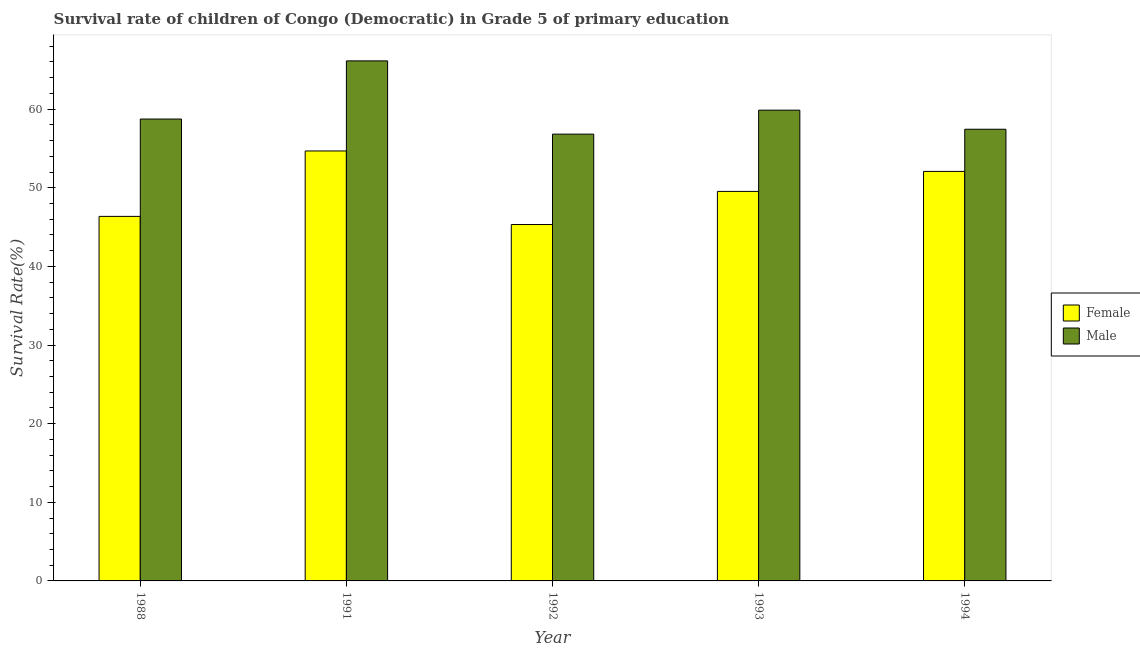How many different coloured bars are there?
Offer a very short reply. 2. Are the number of bars per tick equal to the number of legend labels?
Give a very brief answer. Yes. How many bars are there on the 4th tick from the right?
Give a very brief answer. 2. What is the label of the 2nd group of bars from the left?
Provide a succinct answer. 1991. In how many cases, is the number of bars for a given year not equal to the number of legend labels?
Give a very brief answer. 0. What is the survival rate of male students in primary education in 1992?
Make the answer very short. 56.82. Across all years, what is the maximum survival rate of female students in primary education?
Offer a very short reply. 54.68. Across all years, what is the minimum survival rate of female students in primary education?
Your response must be concise. 45.32. What is the total survival rate of female students in primary education in the graph?
Offer a terse response. 247.98. What is the difference between the survival rate of male students in primary education in 1993 and that in 1994?
Give a very brief answer. 2.43. What is the difference between the survival rate of female students in primary education in 1988 and the survival rate of male students in primary education in 1993?
Your answer should be very brief. -3.18. What is the average survival rate of female students in primary education per year?
Provide a short and direct response. 49.6. In the year 1992, what is the difference between the survival rate of female students in primary education and survival rate of male students in primary education?
Give a very brief answer. 0. What is the ratio of the survival rate of male students in primary education in 1988 to that in 1991?
Your response must be concise. 0.89. What is the difference between the highest and the second highest survival rate of female students in primary education?
Give a very brief answer. 2.6. What is the difference between the highest and the lowest survival rate of male students in primary education?
Give a very brief answer. 9.32. What does the 1st bar from the right in 1988 represents?
Provide a succinct answer. Male. Are all the bars in the graph horizontal?
Ensure brevity in your answer.  No. Does the graph contain grids?
Your response must be concise. No. How many legend labels are there?
Offer a very short reply. 2. How are the legend labels stacked?
Your answer should be very brief. Vertical. What is the title of the graph?
Your response must be concise. Survival rate of children of Congo (Democratic) in Grade 5 of primary education. What is the label or title of the X-axis?
Keep it short and to the point. Year. What is the label or title of the Y-axis?
Provide a short and direct response. Survival Rate(%). What is the Survival Rate(%) in Female in 1988?
Offer a terse response. 46.36. What is the Survival Rate(%) in Male in 1988?
Provide a short and direct response. 58.74. What is the Survival Rate(%) in Female in 1991?
Keep it short and to the point. 54.68. What is the Survival Rate(%) in Male in 1991?
Ensure brevity in your answer.  66.14. What is the Survival Rate(%) of Female in 1992?
Offer a very short reply. 45.32. What is the Survival Rate(%) of Male in 1992?
Offer a terse response. 56.82. What is the Survival Rate(%) in Female in 1993?
Keep it short and to the point. 49.54. What is the Survival Rate(%) in Male in 1993?
Your answer should be compact. 59.87. What is the Survival Rate(%) in Female in 1994?
Ensure brevity in your answer.  52.08. What is the Survival Rate(%) of Male in 1994?
Your answer should be very brief. 57.44. Across all years, what is the maximum Survival Rate(%) in Female?
Give a very brief answer. 54.68. Across all years, what is the maximum Survival Rate(%) in Male?
Your answer should be very brief. 66.14. Across all years, what is the minimum Survival Rate(%) of Female?
Offer a terse response. 45.32. Across all years, what is the minimum Survival Rate(%) in Male?
Your response must be concise. 56.82. What is the total Survival Rate(%) of Female in the graph?
Provide a succinct answer. 247.98. What is the total Survival Rate(%) in Male in the graph?
Provide a short and direct response. 299. What is the difference between the Survival Rate(%) in Female in 1988 and that in 1991?
Your answer should be compact. -8.32. What is the difference between the Survival Rate(%) of Male in 1988 and that in 1991?
Keep it short and to the point. -7.4. What is the difference between the Survival Rate(%) of Female in 1988 and that in 1992?
Provide a short and direct response. 1.04. What is the difference between the Survival Rate(%) in Male in 1988 and that in 1992?
Your answer should be compact. 1.92. What is the difference between the Survival Rate(%) in Female in 1988 and that in 1993?
Your answer should be very brief. -3.18. What is the difference between the Survival Rate(%) in Male in 1988 and that in 1993?
Provide a succinct answer. -1.13. What is the difference between the Survival Rate(%) in Female in 1988 and that in 1994?
Your response must be concise. -5.72. What is the difference between the Survival Rate(%) of Male in 1988 and that in 1994?
Offer a terse response. 1.3. What is the difference between the Survival Rate(%) in Female in 1991 and that in 1992?
Keep it short and to the point. 9.35. What is the difference between the Survival Rate(%) of Male in 1991 and that in 1992?
Offer a very short reply. 9.32. What is the difference between the Survival Rate(%) of Female in 1991 and that in 1993?
Provide a succinct answer. 5.14. What is the difference between the Survival Rate(%) of Male in 1991 and that in 1993?
Give a very brief answer. 6.27. What is the difference between the Survival Rate(%) in Female in 1991 and that in 1994?
Offer a terse response. 2.6. What is the difference between the Survival Rate(%) in Male in 1991 and that in 1994?
Keep it short and to the point. 8.69. What is the difference between the Survival Rate(%) of Female in 1992 and that in 1993?
Offer a very short reply. -4.21. What is the difference between the Survival Rate(%) of Male in 1992 and that in 1993?
Make the answer very short. -3.05. What is the difference between the Survival Rate(%) of Female in 1992 and that in 1994?
Give a very brief answer. -6.75. What is the difference between the Survival Rate(%) of Male in 1992 and that in 1994?
Your answer should be very brief. -0.62. What is the difference between the Survival Rate(%) of Female in 1993 and that in 1994?
Provide a short and direct response. -2.54. What is the difference between the Survival Rate(%) of Male in 1993 and that in 1994?
Keep it short and to the point. 2.43. What is the difference between the Survival Rate(%) of Female in 1988 and the Survival Rate(%) of Male in 1991?
Offer a very short reply. -19.78. What is the difference between the Survival Rate(%) in Female in 1988 and the Survival Rate(%) in Male in 1992?
Your answer should be very brief. -10.46. What is the difference between the Survival Rate(%) of Female in 1988 and the Survival Rate(%) of Male in 1993?
Make the answer very short. -13.51. What is the difference between the Survival Rate(%) in Female in 1988 and the Survival Rate(%) in Male in 1994?
Your answer should be very brief. -11.08. What is the difference between the Survival Rate(%) of Female in 1991 and the Survival Rate(%) of Male in 1992?
Give a very brief answer. -2.14. What is the difference between the Survival Rate(%) in Female in 1991 and the Survival Rate(%) in Male in 1993?
Give a very brief answer. -5.19. What is the difference between the Survival Rate(%) of Female in 1991 and the Survival Rate(%) of Male in 1994?
Your response must be concise. -2.76. What is the difference between the Survival Rate(%) of Female in 1992 and the Survival Rate(%) of Male in 1993?
Provide a short and direct response. -14.54. What is the difference between the Survival Rate(%) in Female in 1992 and the Survival Rate(%) in Male in 1994?
Offer a terse response. -12.12. What is the difference between the Survival Rate(%) of Female in 1993 and the Survival Rate(%) of Male in 1994?
Your response must be concise. -7.9. What is the average Survival Rate(%) of Female per year?
Offer a very short reply. 49.6. What is the average Survival Rate(%) in Male per year?
Provide a succinct answer. 59.8. In the year 1988, what is the difference between the Survival Rate(%) in Female and Survival Rate(%) in Male?
Give a very brief answer. -12.38. In the year 1991, what is the difference between the Survival Rate(%) of Female and Survival Rate(%) of Male?
Ensure brevity in your answer.  -11.46. In the year 1992, what is the difference between the Survival Rate(%) in Female and Survival Rate(%) in Male?
Keep it short and to the point. -11.5. In the year 1993, what is the difference between the Survival Rate(%) in Female and Survival Rate(%) in Male?
Offer a very short reply. -10.33. In the year 1994, what is the difference between the Survival Rate(%) of Female and Survival Rate(%) of Male?
Keep it short and to the point. -5.36. What is the ratio of the Survival Rate(%) in Female in 1988 to that in 1991?
Your answer should be very brief. 0.85. What is the ratio of the Survival Rate(%) in Male in 1988 to that in 1991?
Make the answer very short. 0.89. What is the ratio of the Survival Rate(%) of Female in 1988 to that in 1992?
Offer a terse response. 1.02. What is the ratio of the Survival Rate(%) of Male in 1988 to that in 1992?
Give a very brief answer. 1.03. What is the ratio of the Survival Rate(%) in Female in 1988 to that in 1993?
Offer a very short reply. 0.94. What is the ratio of the Survival Rate(%) in Male in 1988 to that in 1993?
Provide a short and direct response. 0.98. What is the ratio of the Survival Rate(%) of Female in 1988 to that in 1994?
Provide a short and direct response. 0.89. What is the ratio of the Survival Rate(%) in Male in 1988 to that in 1994?
Provide a succinct answer. 1.02. What is the ratio of the Survival Rate(%) of Female in 1991 to that in 1992?
Offer a terse response. 1.21. What is the ratio of the Survival Rate(%) of Male in 1991 to that in 1992?
Your response must be concise. 1.16. What is the ratio of the Survival Rate(%) in Female in 1991 to that in 1993?
Your response must be concise. 1.1. What is the ratio of the Survival Rate(%) in Male in 1991 to that in 1993?
Provide a short and direct response. 1.1. What is the ratio of the Survival Rate(%) of Female in 1991 to that in 1994?
Offer a terse response. 1.05. What is the ratio of the Survival Rate(%) in Male in 1991 to that in 1994?
Offer a very short reply. 1.15. What is the ratio of the Survival Rate(%) of Female in 1992 to that in 1993?
Give a very brief answer. 0.92. What is the ratio of the Survival Rate(%) of Male in 1992 to that in 1993?
Your answer should be compact. 0.95. What is the ratio of the Survival Rate(%) in Female in 1992 to that in 1994?
Provide a short and direct response. 0.87. What is the ratio of the Survival Rate(%) of Female in 1993 to that in 1994?
Offer a very short reply. 0.95. What is the ratio of the Survival Rate(%) of Male in 1993 to that in 1994?
Provide a succinct answer. 1.04. What is the difference between the highest and the second highest Survival Rate(%) of Female?
Your answer should be very brief. 2.6. What is the difference between the highest and the second highest Survival Rate(%) in Male?
Give a very brief answer. 6.27. What is the difference between the highest and the lowest Survival Rate(%) of Female?
Give a very brief answer. 9.35. What is the difference between the highest and the lowest Survival Rate(%) in Male?
Offer a very short reply. 9.32. 